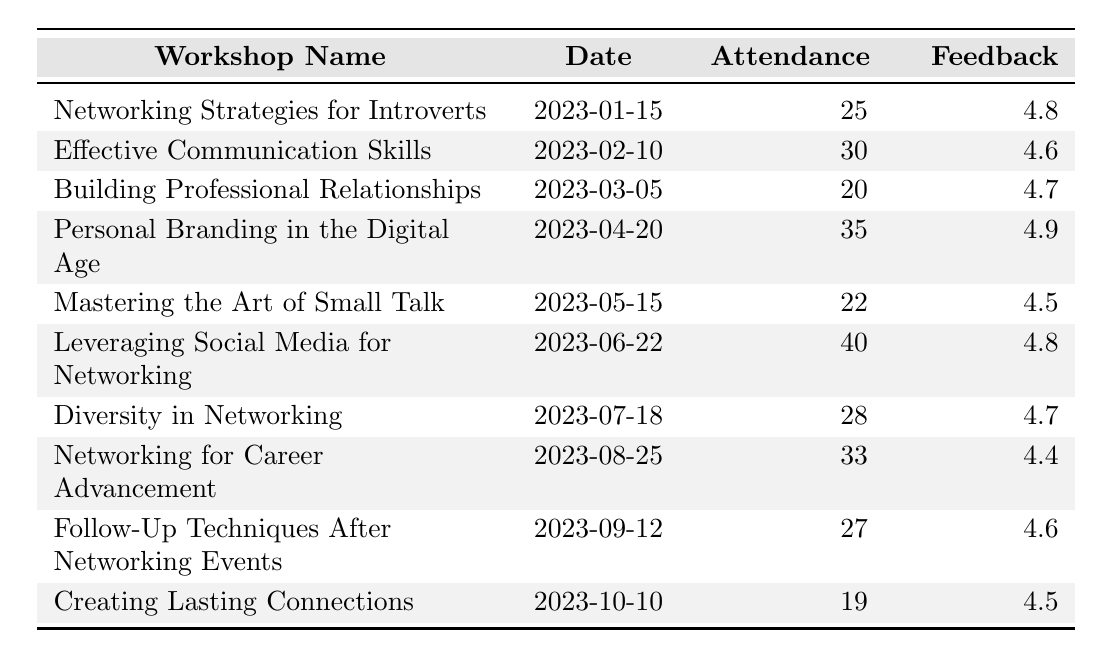What was the date of the workshop "Personal Branding in the Digital Age"? The date is directly listed in the respective row, next to the workshop name "Personal Branding in the Digital Age", which is 2023-04-20.
Answer: 2023-04-20 How many attendees were there at the "Leveraging Social Media for Networking" workshop? The attendance number is stated in the row for "Leveraging Social Media for Networking", which shows the number of attendees as 40.
Answer: 40 What is the highest feedback rating from all workshops? The feedback ratings are in the column for feedback. Scanning through the list, the highest rating is 4.9 for "Personal Branding in the Digital Age".
Answer: 4.9 What was the average attendance across all workshops? First, sum the attendance numbers: 25 + 30 + 20 + 35 + 22 + 40 + 28 + 33 + 27 + 19 =  309. Then, divide by the number of workshops (10): 309 / 10 = 30.9.
Answer: 30.9 Did the "Creating Lasting Connections" workshop have a higher feedback rating than the "Mastering the Art of Small Talk"? Checking the feedback ratings, "Creating Lasting Connections" has a rating of 4.5 and "Mastering the Art of Small Talk" has a rating of 4.5 as well. Since they are equal, the answer is no.
Answer: No Which workshop had the lowest attendance? The attendance numbers are compared, and the lowest is 19, corresponding to the workshop "Creating Lasting Connections".
Answer: Creating Lasting Connections What is the total feedback rating for the "Networking for Career Advancement" and "Follow-Up Techniques After Networking Events" workshops combined? The feedback ratings for these workshops are 4.4 and 4.6, respectively. Adding them gives: 4.4 + 4.6 = 9.0.
Answer: 9.0 How many workshops had an attendance greater than 30? The workshops with attendance greater than 30 are "Personal Branding in the Digital Age" (35), "Leveraging Social Media for Networking" (40), and "Networking for Career Advancement" (33). Counting these, there are 3 workshops.
Answer: 3 Which workshop date had the highest attendance? Comparing the attendance figures, "Leveraging Social Media for Networking" with attendance of 40 has the highest. The date for this workshop is 2023-06-22.
Answer: 2023-06-22 Was the average feedback rating for all workshops above 4.5? To check, calculate the average of ratings: (4.8 + 4.6 + 4.7 + 4.9 + 4.5 + 4.8 + 4.7 + 4.4 + 4.6 + 4.5) / 10 = 4.6. Since 4.6 is greater than 4.5, the answer is yes.
Answer: Yes 